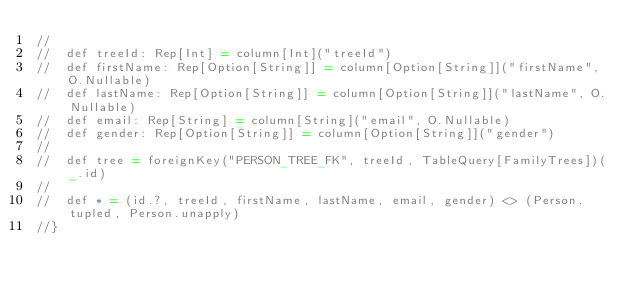<code> <loc_0><loc_0><loc_500><loc_500><_Scala_>//
//  def treeId: Rep[Int] = column[Int]("treeId")
//  def firstName: Rep[Option[String]] = column[Option[String]]("firstName", O.Nullable)
//  def lastName: Rep[Option[String]] = column[Option[String]]("lastName", O.Nullable)
//  def email: Rep[String] = column[String]("email", O.Nullable)
//  def gender: Rep[Option[String]] = column[Option[String]]("gender")
//
//  def tree = foreignKey("PERSON_TREE_FK", treeId, TableQuery[FamilyTrees])(_.id)
//
//  def * = (id.?, treeId, firstName, lastName, email, gender) <> (Person.tupled, Person.unapply)
//}
</code> 